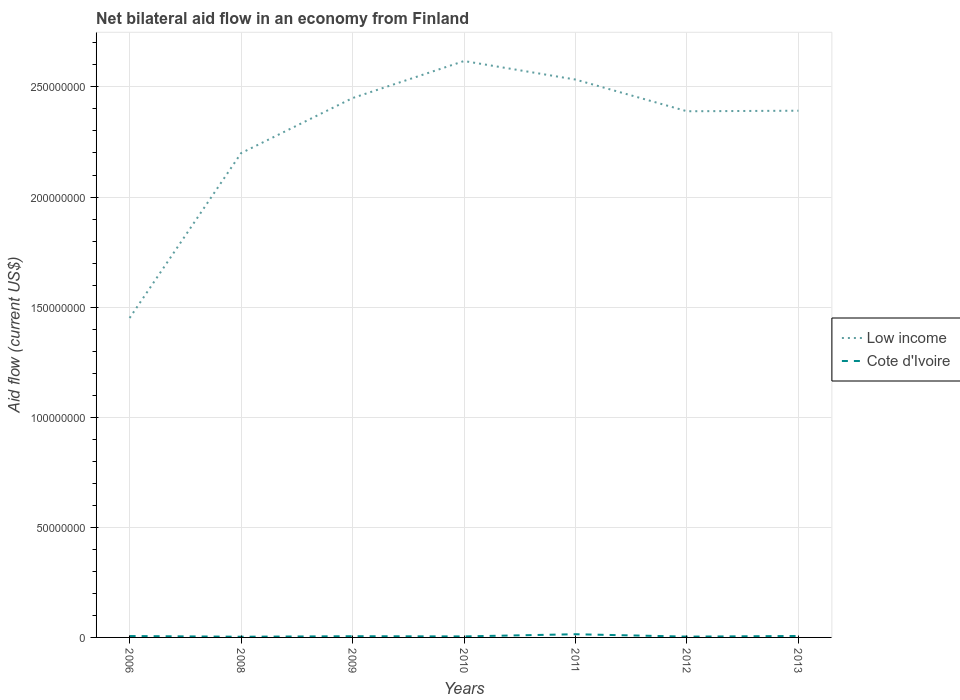Does the line corresponding to Low income intersect with the line corresponding to Cote d'Ivoire?
Make the answer very short. No. Is the number of lines equal to the number of legend labels?
Offer a terse response. Yes. Across all years, what is the maximum net bilateral aid flow in Cote d'Ivoire?
Ensure brevity in your answer.  3.20e+05. In which year was the net bilateral aid flow in Cote d'Ivoire maximum?
Keep it short and to the point. 2008. What is the total net bilateral aid flow in Low income in the graph?
Your response must be concise. -8.41e+06. What is the difference between the highest and the second highest net bilateral aid flow in Cote d'Ivoire?
Provide a succinct answer. 1.13e+06. What is the difference between the highest and the lowest net bilateral aid flow in Cote d'Ivoire?
Keep it short and to the point. 2. Is the net bilateral aid flow in Low income strictly greater than the net bilateral aid flow in Cote d'Ivoire over the years?
Make the answer very short. No. How many years are there in the graph?
Your response must be concise. 7. What is the difference between two consecutive major ticks on the Y-axis?
Make the answer very short. 5.00e+07. Are the values on the major ticks of Y-axis written in scientific E-notation?
Make the answer very short. No. Does the graph contain any zero values?
Make the answer very short. No. How many legend labels are there?
Your answer should be very brief. 2. What is the title of the graph?
Your answer should be compact. Net bilateral aid flow in an economy from Finland. What is the label or title of the Y-axis?
Give a very brief answer. Aid flow (current US$). What is the Aid flow (current US$) in Low income in 2006?
Your answer should be compact. 1.45e+08. What is the Aid flow (current US$) in Cote d'Ivoire in 2006?
Your answer should be very brief. 6.30e+05. What is the Aid flow (current US$) of Low income in 2008?
Offer a very short reply. 2.20e+08. What is the Aid flow (current US$) in Cote d'Ivoire in 2008?
Provide a succinct answer. 3.20e+05. What is the Aid flow (current US$) in Low income in 2009?
Offer a very short reply. 2.45e+08. What is the Aid flow (current US$) in Low income in 2010?
Offer a very short reply. 2.62e+08. What is the Aid flow (current US$) in Cote d'Ivoire in 2010?
Offer a very short reply. 4.60e+05. What is the Aid flow (current US$) in Low income in 2011?
Provide a succinct answer. 2.53e+08. What is the Aid flow (current US$) of Cote d'Ivoire in 2011?
Offer a terse response. 1.45e+06. What is the Aid flow (current US$) in Low income in 2012?
Provide a short and direct response. 2.39e+08. What is the Aid flow (current US$) of Low income in 2013?
Offer a very short reply. 2.39e+08. Across all years, what is the maximum Aid flow (current US$) of Low income?
Offer a terse response. 2.62e+08. Across all years, what is the maximum Aid flow (current US$) in Cote d'Ivoire?
Make the answer very short. 1.45e+06. Across all years, what is the minimum Aid flow (current US$) in Low income?
Provide a succinct answer. 1.45e+08. What is the total Aid flow (current US$) of Low income in the graph?
Offer a terse response. 1.60e+09. What is the total Aid flow (current US$) of Cote d'Ivoire in the graph?
Offer a terse response. 4.44e+06. What is the difference between the Aid flow (current US$) of Low income in 2006 and that in 2008?
Your answer should be very brief. -7.49e+07. What is the difference between the Aid flow (current US$) of Cote d'Ivoire in 2006 and that in 2008?
Offer a very short reply. 3.10e+05. What is the difference between the Aid flow (current US$) of Low income in 2006 and that in 2009?
Your response must be concise. -9.99e+07. What is the difference between the Aid flow (current US$) in Cote d'Ivoire in 2006 and that in 2009?
Your answer should be very brief. 8.00e+04. What is the difference between the Aid flow (current US$) of Low income in 2006 and that in 2010?
Ensure brevity in your answer.  -1.17e+08. What is the difference between the Aid flow (current US$) in Cote d'Ivoire in 2006 and that in 2010?
Your response must be concise. 1.70e+05. What is the difference between the Aid flow (current US$) in Low income in 2006 and that in 2011?
Make the answer very short. -1.08e+08. What is the difference between the Aid flow (current US$) of Cote d'Ivoire in 2006 and that in 2011?
Your answer should be very brief. -8.20e+05. What is the difference between the Aid flow (current US$) of Low income in 2006 and that in 2012?
Offer a very short reply. -9.39e+07. What is the difference between the Aid flow (current US$) of Low income in 2006 and that in 2013?
Provide a succinct answer. -9.41e+07. What is the difference between the Aid flow (current US$) in Cote d'Ivoire in 2006 and that in 2013?
Ensure brevity in your answer.  -3.00e+04. What is the difference between the Aid flow (current US$) of Low income in 2008 and that in 2009?
Provide a succinct answer. -2.50e+07. What is the difference between the Aid flow (current US$) of Cote d'Ivoire in 2008 and that in 2009?
Keep it short and to the point. -2.30e+05. What is the difference between the Aid flow (current US$) of Low income in 2008 and that in 2010?
Make the answer very short. -4.18e+07. What is the difference between the Aid flow (current US$) in Low income in 2008 and that in 2011?
Provide a short and direct response. -3.34e+07. What is the difference between the Aid flow (current US$) in Cote d'Ivoire in 2008 and that in 2011?
Keep it short and to the point. -1.13e+06. What is the difference between the Aid flow (current US$) of Low income in 2008 and that in 2012?
Provide a succinct answer. -1.90e+07. What is the difference between the Aid flow (current US$) in Cote d'Ivoire in 2008 and that in 2012?
Your answer should be compact. -5.00e+04. What is the difference between the Aid flow (current US$) in Low income in 2008 and that in 2013?
Ensure brevity in your answer.  -1.93e+07. What is the difference between the Aid flow (current US$) in Low income in 2009 and that in 2010?
Your response must be concise. -1.68e+07. What is the difference between the Aid flow (current US$) of Cote d'Ivoire in 2009 and that in 2010?
Your answer should be very brief. 9.00e+04. What is the difference between the Aid flow (current US$) of Low income in 2009 and that in 2011?
Keep it short and to the point. -8.41e+06. What is the difference between the Aid flow (current US$) in Cote d'Ivoire in 2009 and that in 2011?
Ensure brevity in your answer.  -9.00e+05. What is the difference between the Aid flow (current US$) in Low income in 2009 and that in 2012?
Offer a terse response. 5.99e+06. What is the difference between the Aid flow (current US$) of Low income in 2009 and that in 2013?
Your response must be concise. 5.74e+06. What is the difference between the Aid flow (current US$) of Cote d'Ivoire in 2009 and that in 2013?
Keep it short and to the point. -1.10e+05. What is the difference between the Aid flow (current US$) of Low income in 2010 and that in 2011?
Make the answer very short. 8.41e+06. What is the difference between the Aid flow (current US$) in Cote d'Ivoire in 2010 and that in 2011?
Give a very brief answer. -9.90e+05. What is the difference between the Aid flow (current US$) of Low income in 2010 and that in 2012?
Make the answer very short. 2.28e+07. What is the difference between the Aid flow (current US$) in Cote d'Ivoire in 2010 and that in 2012?
Keep it short and to the point. 9.00e+04. What is the difference between the Aid flow (current US$) in Low income in 2010 and that in 2013?
Provide a succinct answer. 2.26e+07. What is the difference between the Aid flow (current US$) in Low income in 2011 and that in 2012?
Your response must be concise. 1.44e+07. What is the difference between the Aid flow (current US$) of Cote d'Ivoire in 2011 and that in 2012?
Make the answer very short. 1.08e+06. What is the difference between the Aid flow (current US$) in Low income in 2011 and that in 2013?
Offer a terse response. 1.42e+07. What is the difference between the Aid flow (current US$) in Cote d'Ivoire in 2011 and that in 2013?
Keep it short and to the point. 7.90e+05. What is the difference between the Aid flow (current US$) of Low income in 2012 and that in 2013?
Offer a terse response. -2.50e+05. What is the difference between the Aid flow (current US$) of Low income in 2006 and the Aid flow (current US$) of Cote d'Ivoire in 2008?
Your response must be concise. 1.45e+08. What is the difference between the Aid flow (current US$) of Low income in 2006 and the Aid flow (current US$) of Cote d'Ivoire in 2009?
Provide a short and direct response. 1.45e+08. What is the difference between the Aid flow (current US$) in Low income in 2006 and the Aid flow (current US$) in Cote d'Ivoire in 2010?
Your response must be concise. 1.45e+08. What is the difference between the Aid flow (current US$) of Low income in 2006 and the Aid flow (current US$) of Cote d'Ivoire in 2011?
Provide a short and direct response. 1.44e+08. What is the difference between the Aid flow (current US$) of Low income in 2006 and the Aid flow (current US$) of Cote d'Ivoire in 2012?
Keep it short and to the point. 1.45e+08. What is the difference between the Aid flow (current US$) of Low income in 2006 and the Aid flow (current US$) of Cote d'Ivoire in 2013?
Give a very brief answer. 1.44e+08. What is the difference between the Aid flow (current US$) of Low income in 2008 and the Aid flow (current US$) of Cote d'Ivoire in 2009?
Your response must be concise. 2.19e+08. What is the difference between the Aid flow (current US$) of Low income in 2008 and the Aid flow (current US$) of Cote d'Ivoire in 2010?
Offer a very short reply. 2.19e+08. What is the difference between the Aid flow (current US$) of Low income in 2008 and the Aid flow (current US$) of Cote d'Ivoire in 2011?
Your response must be concise. 2.18e+08. What is the difference between the Aid flow (current US$) in Low income in 2008 and the Aid flow (current US$) in Cote d'Ivoire in 2012?
Your response must be concise. 2.20e+08. What is the difference between the Aid flow (current US$) in Low income in 2008 and the Aid flow (current US$) in Cote d'Ivoire in 2013?
Ensure brevity in your answer.  2.19e+08. What is the difference between the Aid flow (current US$) of Low income in 2009 and the Aid flow (current US$) of Cote d'Ivoire in 2010?
Give a very brief answer. 2.44e+08. What is the difference between the Aid flow (current US$) in Low income in 2009 and the Aid flow (current US$) in Cote d'Ivoire in 2011?
Keep it short and to the point. 2.43e+08. What is the difference between the Aid flow (current US$) of Low income in 2009 and the Aid flow (current US$) of Cote d'Ivoire in 2012?
Your answer should be very brief. 2.45e+08. What is the difference between the Aid flow (current US$) of Low income in 2009 and the Aid flow (current US$) of Cote d'Ivoire in 2013?
Offer a terse response. 2.44e+08. What is the difference between the Aid flow (current US$) in Low income in 2010 and the Aid flow (current US$) in Cote d'Ivoire in 2011?
Give a very brief answer. 2.60e+08. What is the difference between the Aid flow (current US$) in Low income in 2010 and the Aid flow (current US$) in Cote d'Ivoire in 2012?
Provide a short and direct response. 2.61e+08. What is the difference between the Aid flow (current US$) of Low income in 2010 and the Aid flow (current US$) of Cote d'Ivoire in 2013?
Your response must be concise. 2.61e+08. What is the difference between the Aid flow (current US$) in Low income in 2011 and the Aid flow (current US$) in Cote d'Ivoire in 2012?
Keep it short and to the point. 2.53e+08. What is the difference between the Aid flow (current US$) of Low income in 2011 and the Aid flow (current US$) of Cote d'Ivoire in 2013?
Make the answer very short. 2.53e+08. What is the difference between the Aid flow (current US$) in Low income in 2012 and the Aid flow (current US$) in Cote d'Ivoire in 2013?
Keep it short and to the point. 2.38e+08. What is the average Aid flow (current US$) in Low income per year?
Give a very brief answer. 2.29e+08. What is the average Aid flow (current US$) in Cote d'Ivoire per year?
Offer a very short reply. 6.34e+05. In the year 2006, what is the difference between the Aid flow (current US$) in Low income and Aid flow (current US$) in Cote d'Ivoire?
Make the answer very short. 1.44e+08. In the year 2008, what is the difference between the Aid flow (current US$) of Low income and Aid flow (current US$) of Cote d'Ivoire?
Your response must be concise. 2.20e+08. In the year 2009, what is the difference between the Aid flow (current US$) of Low income and Aid flow (current US$) of Cote d'Ivoire?
Make the answer very short. 2.44e+08. In the year 2010, what is the difference between the Aid flow (current US$) of Low income and Aid flow (current US$) of Cote d'Ivoire?
Provide a succinct answer. 2.61e+08. In the year 2011, what is the difference between the Aid flow (current US$) of Low income and Aid flow (current US$) of Cote d'Ivoire?
Offer a terse response. 2.52e+08. In the year 2012, what is the difference between the Aid flow (current US$) of Low income and Aid flow (current US$) of Cote d'Ivoire?
Keep it short and to the point. 2.39e+08. In the year 2013, what is the difference between the Aid flow (current US$) in Low income and Aid flow (current US$) in Cote d'Ivoire?
Ensure brevity in your answer.  2.39e+08. What is the ratio of the Aid flow (current US$) of Low income in 2006 to that in 2008?
Make the answer very short. 0.66. What is the ratio of the Aid flow (current US$) of Cote d'Ivoire in 2006 to that in 2008?
Provide a short and direct response. 1.97. What is the ratio of the Aid flow (current US$) of Low income in 2006 to that in 2009?
Ensure brevity in your answer.  0.59. What is the ratio of the Aid flow (current US$) of Cote d'Ivoire in 2006 to that in 2009?
Give a very brief answer. 1.15. What is the ratio of the Aid flow (current US$) in Low income in 2006 to that in 2010?
Ensure brevity in your answer.  0.55. What is the ratio of the Aid flow (current US$) of Cote d'Ivoire in 2006 to that in 2010?
Make the answer very short. 1.37. What is the ratio of the Aid flow (current US$) in Low income in 2006 to that in 2011?
Provide a succinct answer. 0.57. What is the ratio of the Aid flow (current US$) of Cote d'Ivoire in 2006 to that in 2011?
Give a very brief answer. 0.43. What is the ratio of the Aid flow (current US$) of Low income in 2006 to that in 2012?
Provide a short and direct response. 0.61. What is the ratio of the Aid flow (current US$) of Cote d'Ivoire in 2006 to that in 2012?
Provide a short and direct response. 1.7. What is the ratio of the Aid flow (current US$) in Low income in 2006 to that in 2013?
Your response must be concise. 0.61. What is the ratio of the Aid flow (current US$) of Cote d'Ivoire in 2006 to that in 2013?
Make the answer very short. 0.95. What is the ratio of the Aid flow (current US$) of Low income in 2008 to that in 2009?
Your answer should be very brief. 0.9. What is the ratio of the Aid flow (current US$) in Cote d'Ivoire in 2008 to that in 2009?
Offer a very short reply. 0.58. What is the ratio of the Aid flow (current US$) in Low income in 2008 to that in 2010?
Give a very brief answer. 0.84. What is the ratio of the Aid flow (current US$) in Cote d'Ivoire in 2008 to that in 2010?
Provide a succinct answer. 0.7. What is the ratio of the Aid flow (current US$) of Low income in 2008 to that in 2011?
Provide a short and direct response. 0.87. What is the ratio of the Aid flow (current US$) in Cote d'Ivoire in 2008 to that in 2011?
Provide a succinct answer. 0.22. What is the ratio of the Aid flow (current US$) of Low income in 2008 to that in 2012?
Your response must be concise. 0.92. What is the ratio of the Aid flow (current US$) of Cote d'Ivoire in 2008 to that in 2012?
Your response must be concise. 0.86. What is the ratio of the Aid flow (current US$) of Low income in 2008 to that in 2013?
Your response must be concise. 0.92. What is the ratio of the Aid flow (current US$) in Cote d'Ivoire in 2008 to that in 2013?
Provide a short and direct response. 0.48. What is the ratio of the Aid flow (current US$) in Low income in 2009 to that in 2010?
Give a very brief answer. 0.94. What is the ratio of the Aid flow (current US$) of Cote d'Ivoire in 2009 to that in 2010?
Your response must be concise. 1.2. What is the ratio of the Aid flow (current US$) in Low income in 2009 to that in 2011?
Offer a terse response. 0.97. What is the ratio of the Aid flow (current US$) of Cote d'Ivoire in 2009 to that in 2011?
Offer a very short reply. 0.38. What is the ratio of the Aid flow (current US$) of Low income in 2009 to that in 2012?
Provide a succinct answer. 1.03. What is the ratio of the Aid flow (current US$) in Cote d'Ivoire in 2009 to that in 2012?
Make the answer very short. 1.49. What is the ratio of the Aid flow (current US$) in Cote d'Ivoire in 2009 to that in 2013?
Your answer should be compact. 0.83. What is the ratio of the Aid flow (current US$) in Low income in 2010 to that in 2011?
Your response must be concise. 1.03. What is the ratio of the Aid flow (current US$) in Cote d'Ivoire in 2010 to that in 2011?
Your answer should be compact. 0.32. What is the ratio of the Aid flow (current US$) in Low income in 2010 to that in 2012?
Keep it short and to the point. 1.1. What is the ratio of the Aid flow (current US$) of Cote d'Ivoire in 2010 to that in 2012?
Make the answer very short. 1.24. What is the ratio of the Aid flow (current US$) of Low income in 2010 to that in 2013?
Provide a short and direct response. 1.09. What is the ratio of the Aid flow (current US$) in Cote d'Ivoire in 2010 to that in 2013?
Your answer should be compact. 0.7. What is the ratio of the Aid flow (current US$) of Low income in 2011 to that in 2012?
Your answer should be very brief. 1.06. What is the ratio of the Aid flow (current US$) of Cote d'Ivoire in 2011 to that in 2012?
Make the answer very short. 3.92. What is the ratio of the Aid flow (current US$) of Low income in 2011 to that in 2013?
Make the answer very short. 1.06. What is the ratio of the Aid flow (current US$) in Cote d'Ivoire in 2011 to that in 2013?
Keep it short and to the point. 2.2. What is the ratio of the Aid flow (current US$) of Low income in 2012 to that in 2013?
Your answer should be compact. 1. What is the ratio of the Aid flow (current US$) in Cote d'Ivoire in 2012 to that in 2013?
Ensure brevity in your answer.  0.56. What is the difference between the highest and the second highest Aid flow (current US$) in Low income?
Keep it short and to the point. 8.41e+06. What is the difference between the highest and the second highest Aid flow (current US$) in Cote d'Ivoire?
Provide a short and direct response. 7.90e+05. What is the difference between the highest and the lowest Aid flow (current US$) of Low income?
Keep it short and to the point. 1.17e+08. What is the difference between the highest and the lowest Aid flow (current US$) of Cote d'Ivoire?
Offer a terse response. 1.13e+06. 